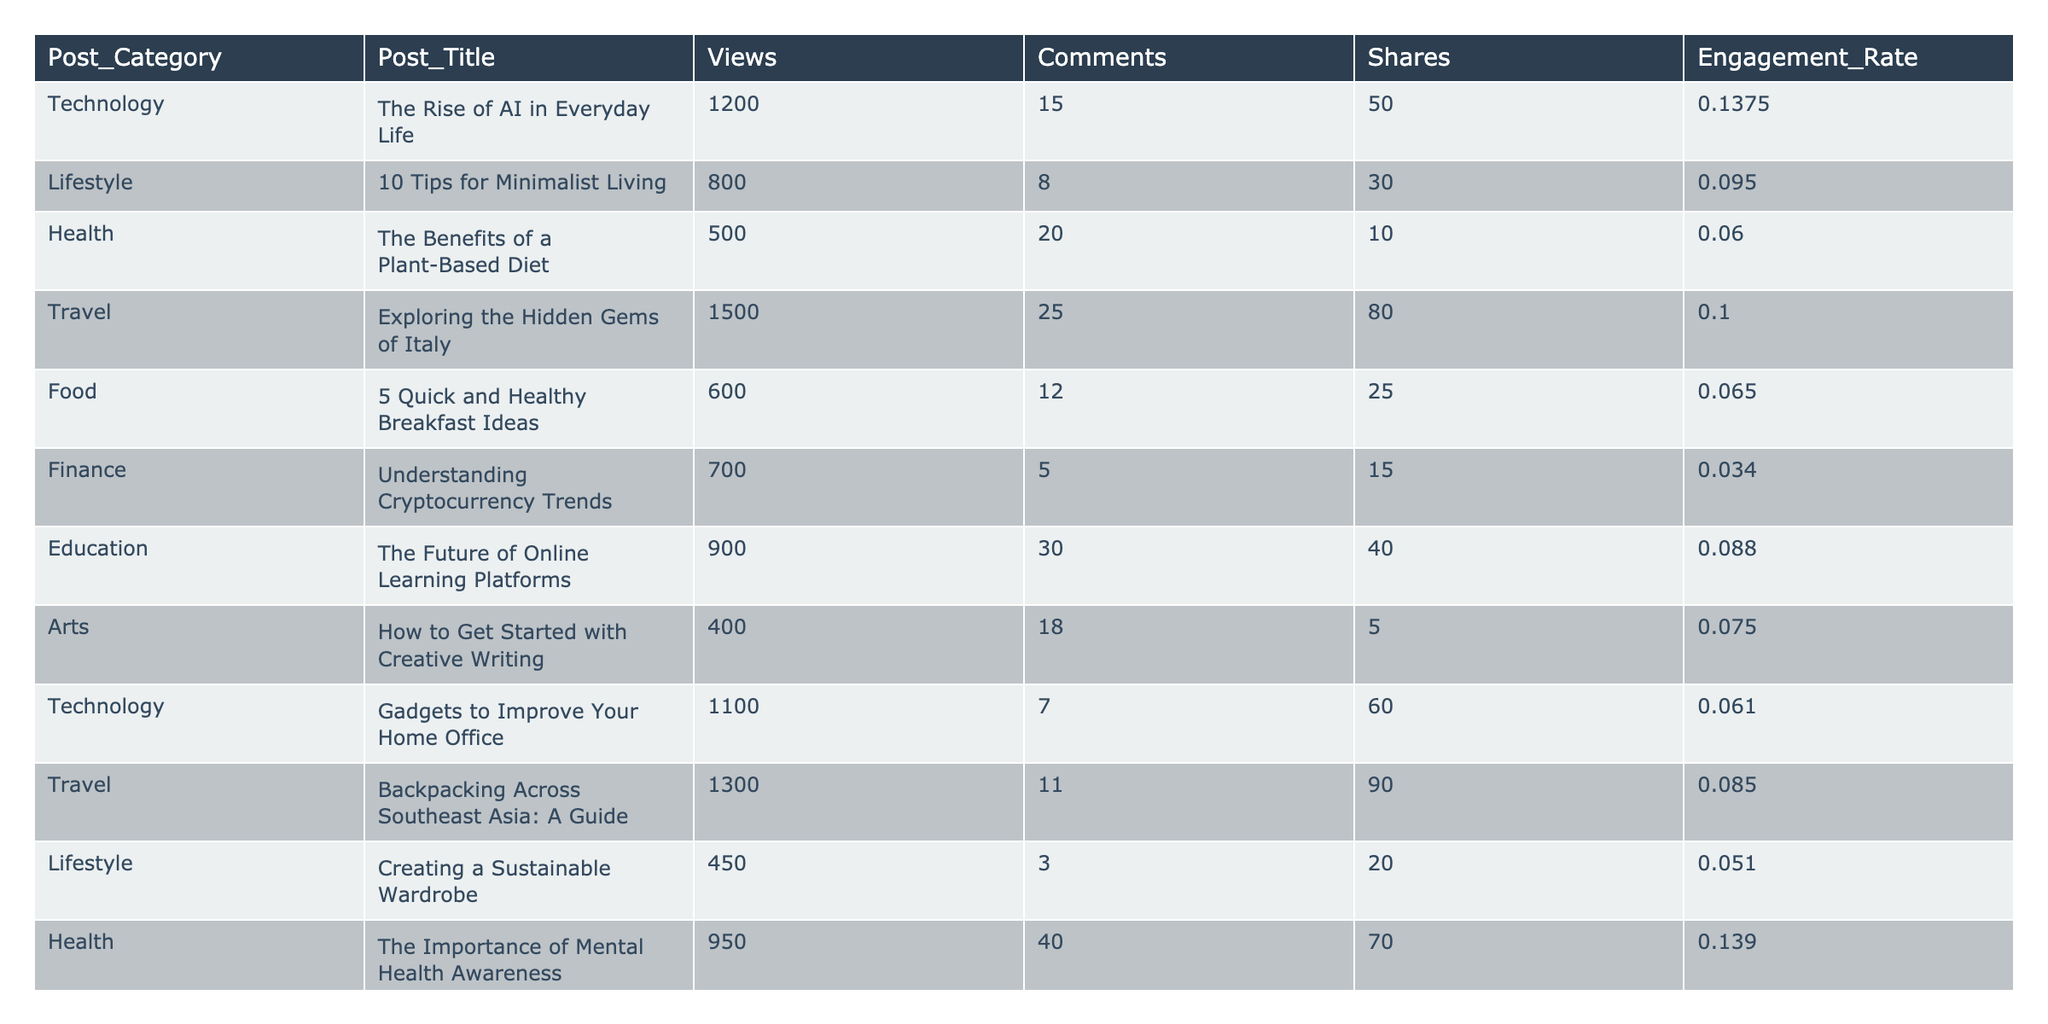What is the highest engagement rate among the posts? We check the column for engagement rates and find that the highest value is 0.1395, which corresponds to the post "The Importance of Mental Health Awareness."
Answer: 0.1395 Which post received the most views? Looking at the views column, we see that "Exploring the Hidden Gems of Italy" has the highest number of views at 1500.
Answer: 1500 How many comments did the "Gadgets to Improve Your Home Office" post receive? The table shows that "Gadgets to Improve Your Home Office" received 7 comments.
Answer: 7 What is the average number of shares for all posts combined? We sum up the shares (50 + 30 + 10 + 80 + 25 + 15 + 40 + 5 + 60 + 90 + 20 + 10 + 35 + 20) = 445. The total number of posts is 14, so the average shares are 445 / 14 ≈ 31.79.
Answer: 31.79 Is the engagement rate for "Understanding Cryptocurrency Trends" above 0.05? The engagement rate for "Understanding Cryptocurrency Trends" is 0.034, which is below 0.05. Thus, the statement is false.
Answer: No What is the total number of views for posts in the "Travel" category? The views for the "Travel" posts are 1500 (first post) + 1300 (second post) = 2800.
Answer: 2800 Which post from the "Health" category had the highest engagement rate? The engagements rates for "The Benefits of a Plant-Based Diet" is 0.06 and for "The Importance of Mental Health Awareness" is 0.139. Therefore, "The Importance of Mental Health Awareness" had the highest engagement rate in the Health category.
Answer: The Importance of Mental Health Awareness What is the difference in views between the most and least viewed posts? The most viewed post has 1500 views and the least viewed post has 400 views, so the difference is 1500 - 400 = 1100.
Answer: 1100 How many posts have an engagement rate greater than 0.1? Checking the engagement rates, we find that "The Rise of AI in Everyday Life" (0.1375) and "The Importance of Mental Health Awareness" (0.139) are the only posts greater than 0.1. Therefore, there are 2 such posts.
Answer: 2 What percentage of total views do posts in the "Technology" category account for? The technology posts have views of 1200 (first post) + 1100 (second post) = 2300. The total views across all posts is 1200 + 800 + 500 + 1500 + 600 + 700 + 900 + 400 + 1100 + 1300 + 450 + 950 + 550 + 600 = 10100. The percentage is (2300 / 10100) * 100 ≈ 22.77%.
Answer: 22.77% 